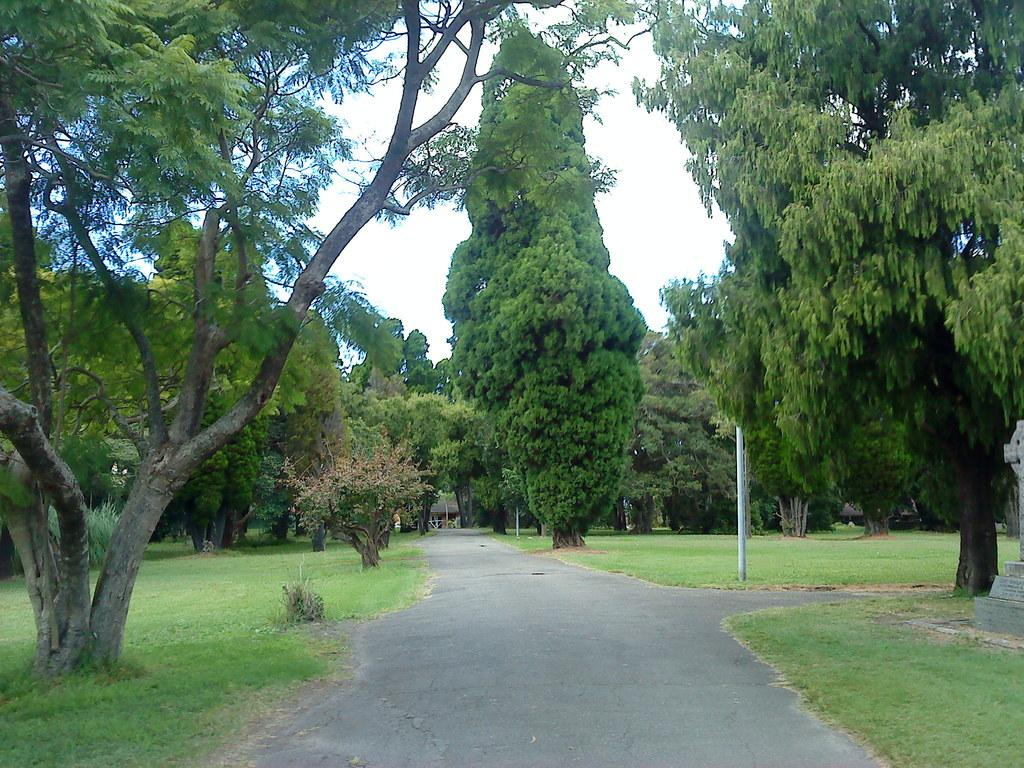What type of vegetation can be seen in the image? There are many trees and plants in the image. What else can be seen in the image besides vegetation? There are poles, grass, a house, walkways, and the sky visible in the image. Can you describe the ground in the image? The ground in the image is covered with grass and has walkways at the bottom. What is visible in the background of the image? The sky is visible in the background of the image. What type of tub is visible in the image? There is no tub present in the image. Who is the governor in the image? There is no mention of a governor or any political figures in the image. 